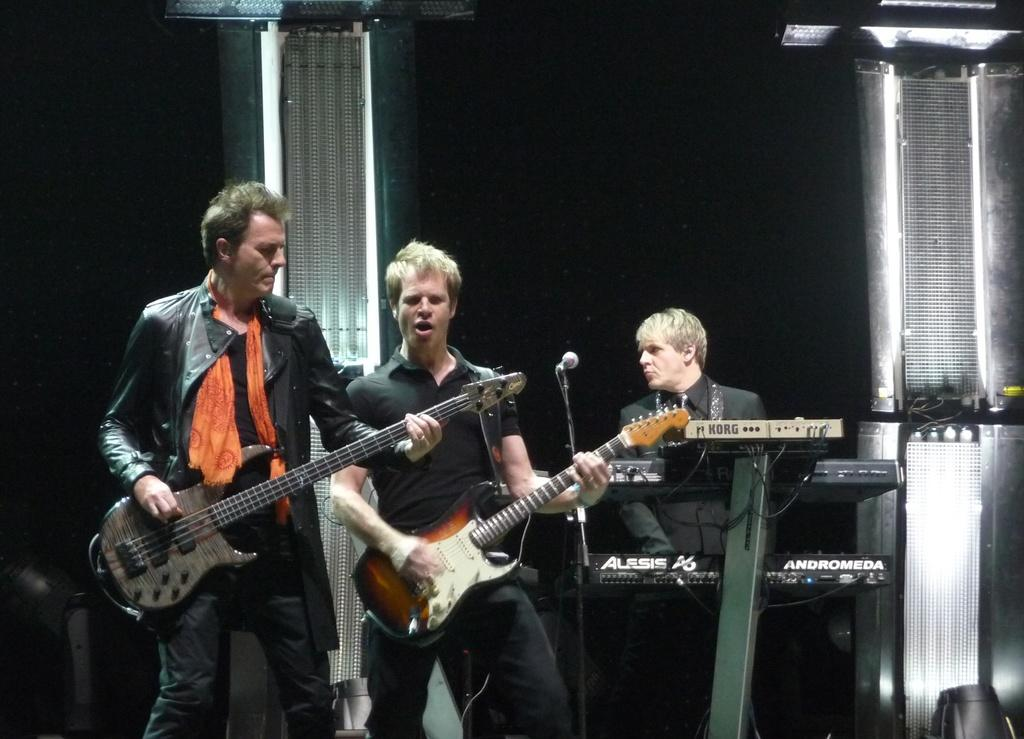How many people are in the image? There are two people in the image. What are the two people holding? The two people are holding guitars. What are the two people doing? The two people are singing. Can you describe the man in the image? The man in the image is playing a musical keyboard. How many frogs are sitting on the musical keyboard in the image? There are no frogs present in the image, and therefore no frogs are sitting on the musical keyboard. 